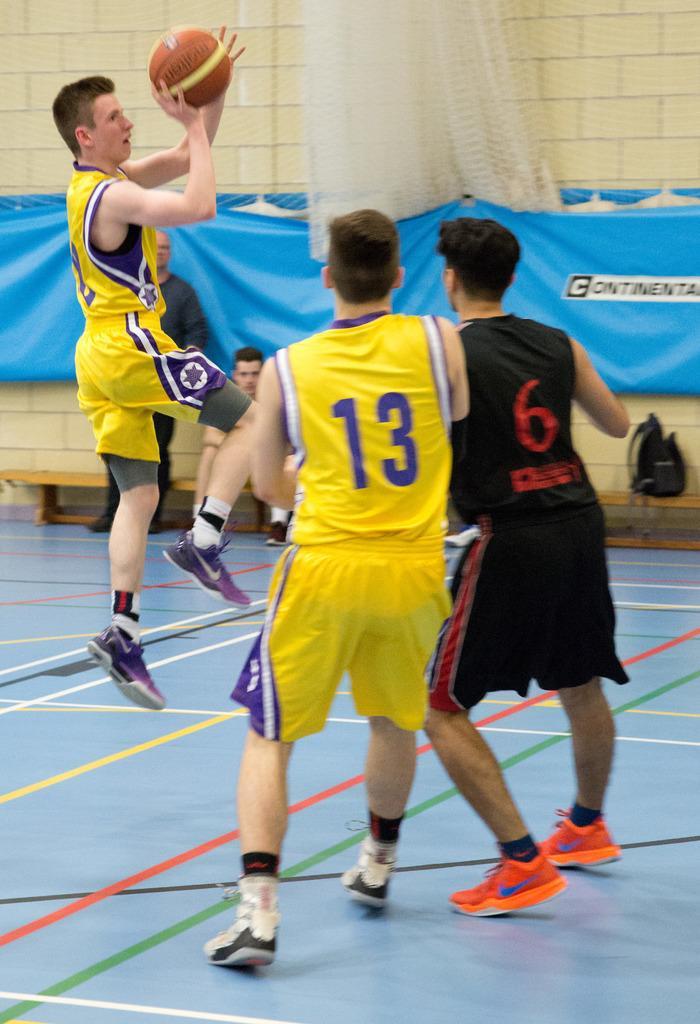Could you give a brief overview of what you see in this image? There are three persons playing basketball. Person on the left is jumping and holding a ball. And they are having numbers on the dress. In the back there's a wall. A blue color sheet is on the wall. Also there are benches. On that there is a bag and a person is sitting. Also there is a net in the back. 